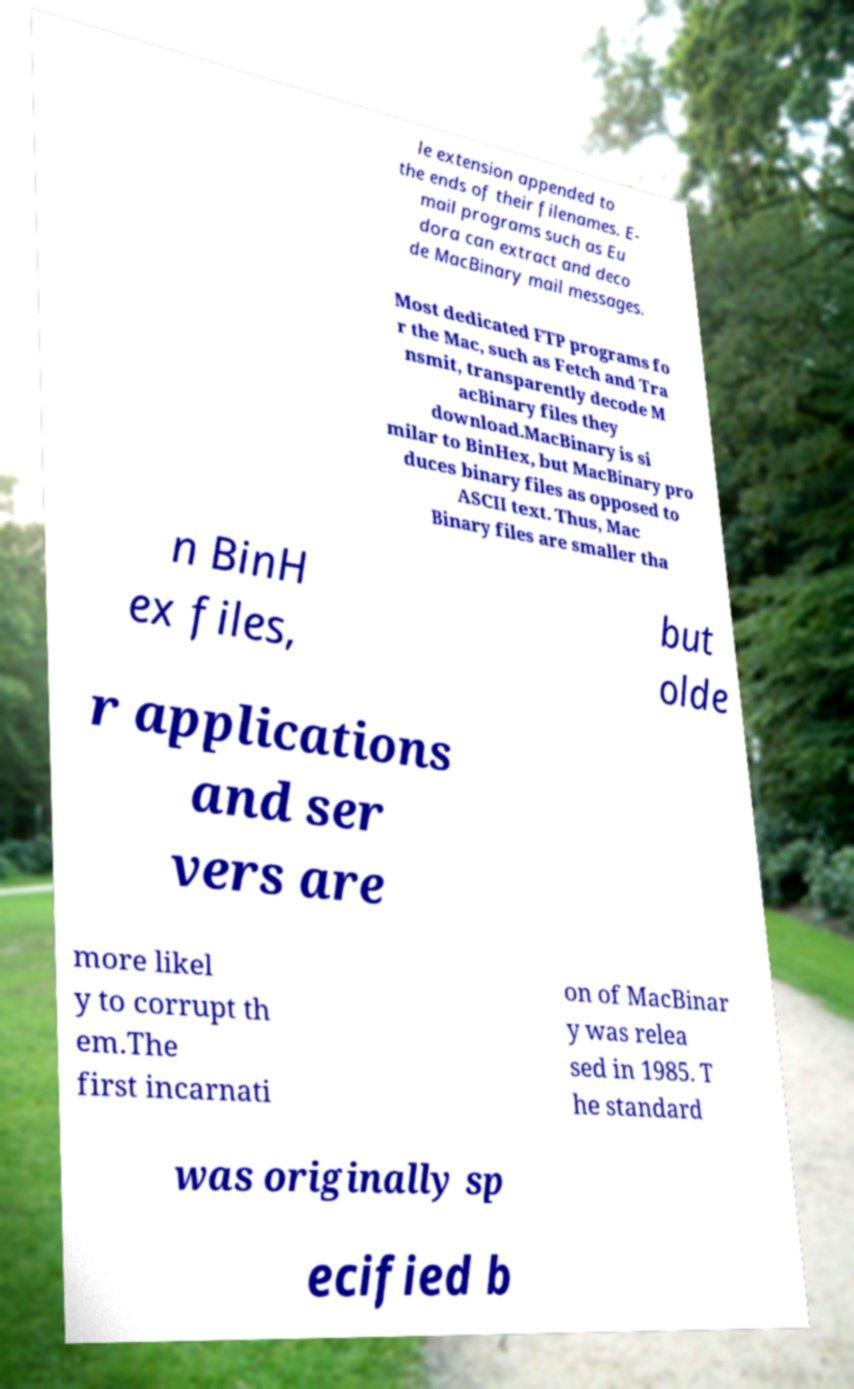Can you read and provide the text displayed in the image?This photo seems to have some interesting text. Can you extract and type it out for me? le extension appended to the ends of their filenames. E- mail programs such as Eu dora can extract and deco de MacBinary mail messages. Most dedicated FTP programs fo r the Mac, such as Fetch and Tra nsmit, transparently decode M acBinary files they download.MacBinary is si milar to BinHex, but MacBinary pro duces binary files as opposed to ASCII text. Thus, Mac Binary files are smaller tha n BinH ex files, but olde r applications and ser vers are more likel y to corrupt th em.The first incarnati on of MacBinar y was relea sed in 1985. T he standard was originally sp ecified b 